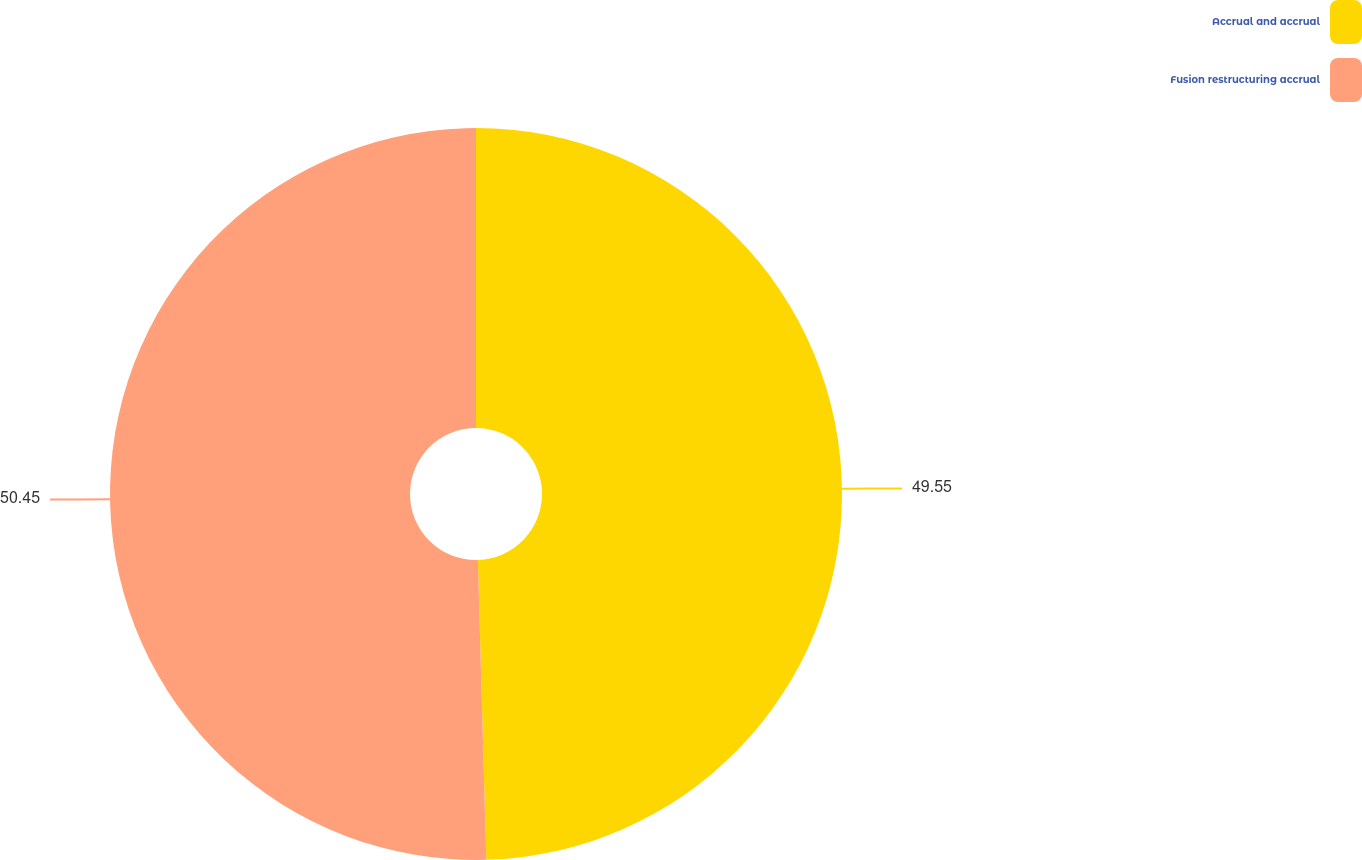Convert chart. <chart><loc_0><loc_0><loc_500><loc_500><pie_chart><fcel>Accrual and accrual<fcel>Fusion restructuring accrual<nl><fcel>49.55%<fcel>50.45%<nl></chart> 